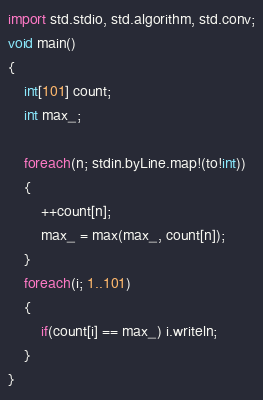<code> <loc_0><loc_0><loc_500><loc_500><_D_>import std.stdio, std.algorithm, std.conv;
void main()
{
    int[101] count;
    int max_;

    foreach(n; stdin.byLine.map!(to!int))
    {
        ++count[n];
        max_ = max(max_, count[n]);
    }
    foreach(i; 1..101)
    {
        if(count[i] == max_) i.writeln;
    }
}</code> 